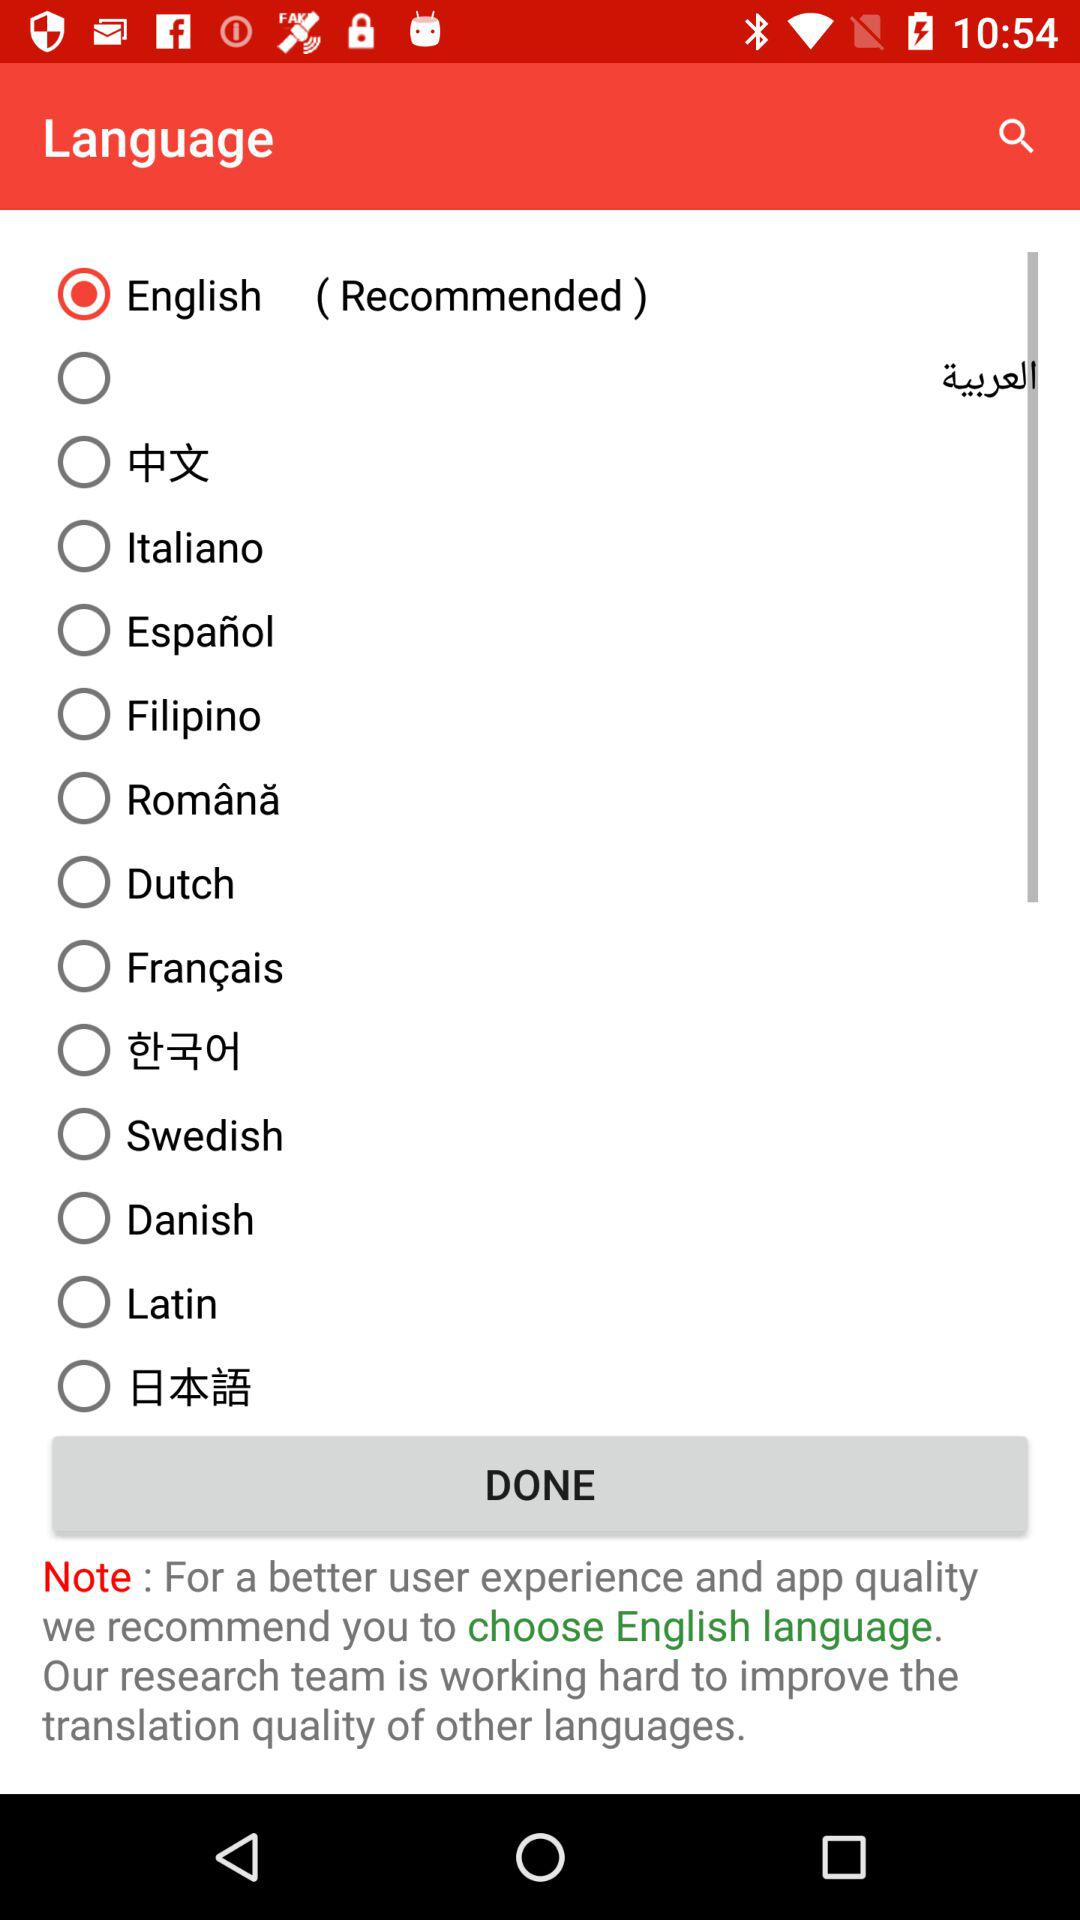Which language is recommended by the app?
Answer the question using a single word or phrase. English 